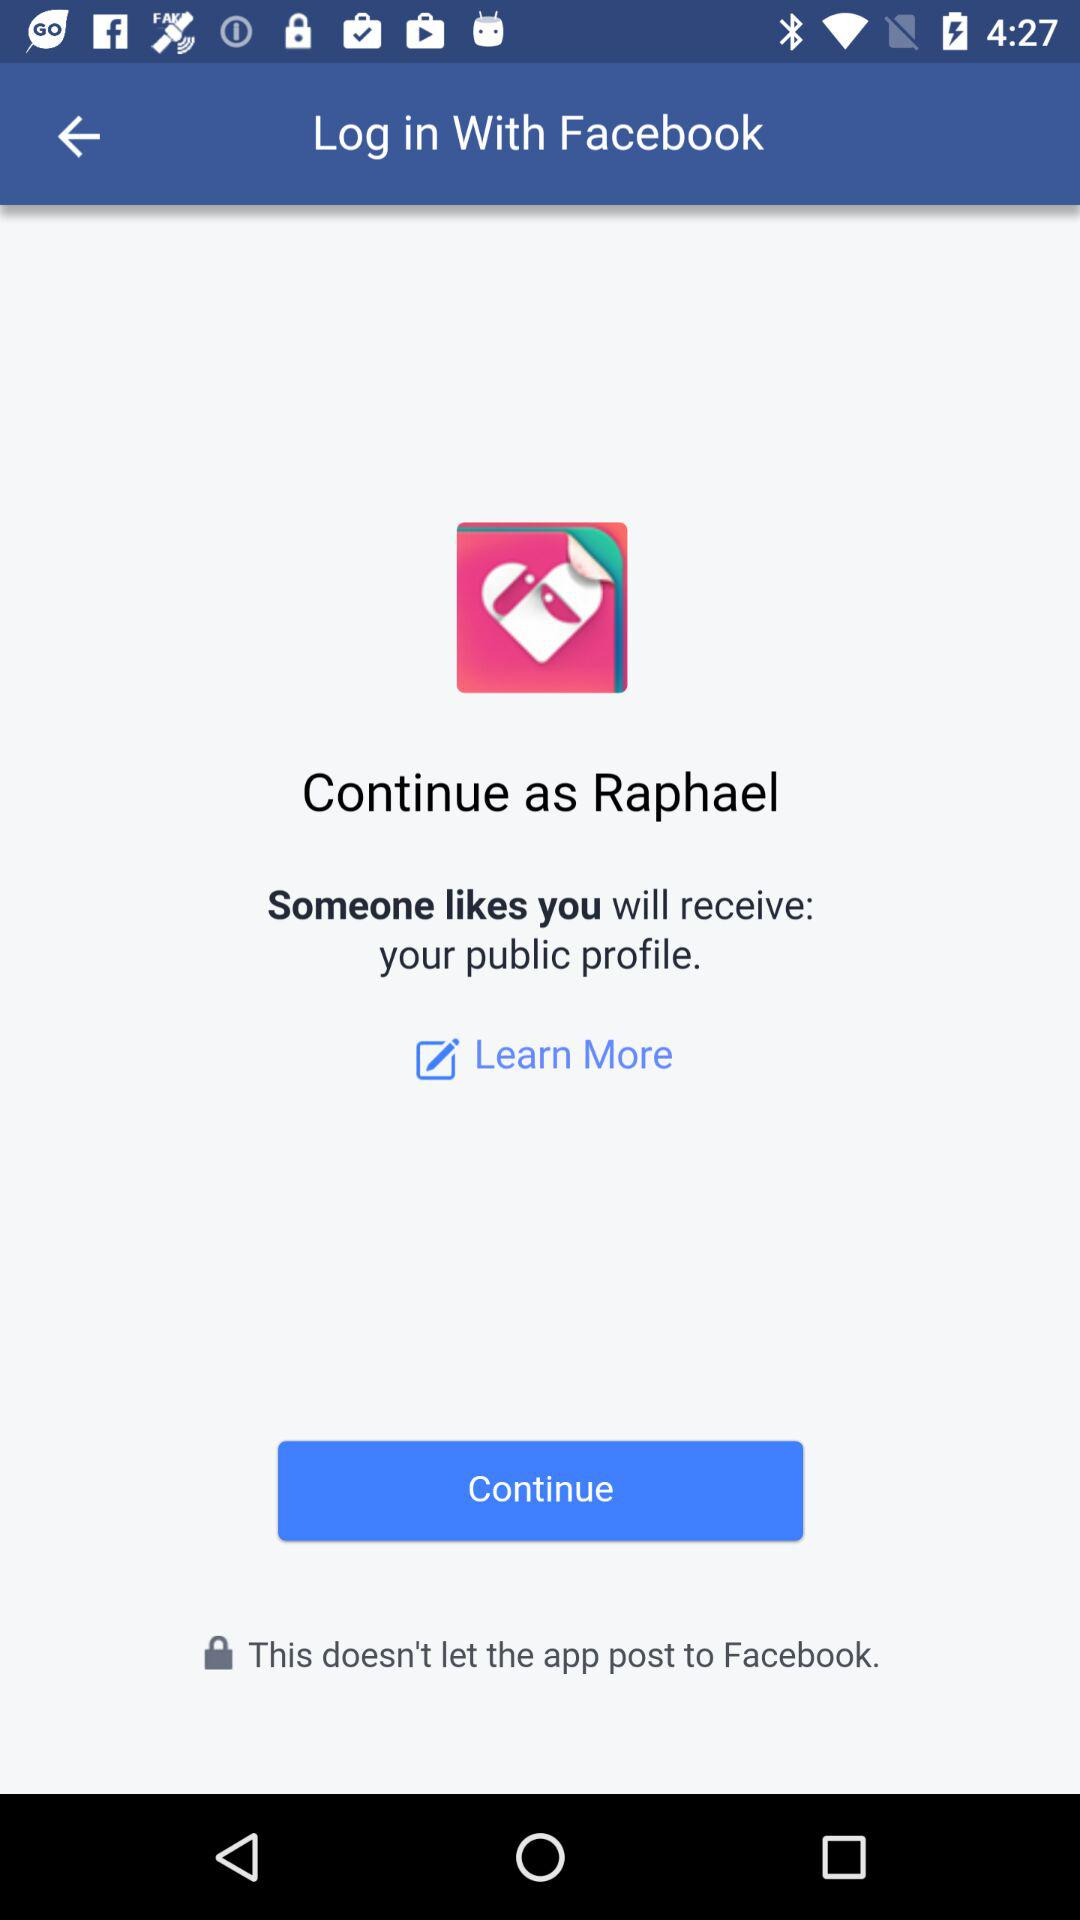How can we log in? You can log in with "Facebook". 